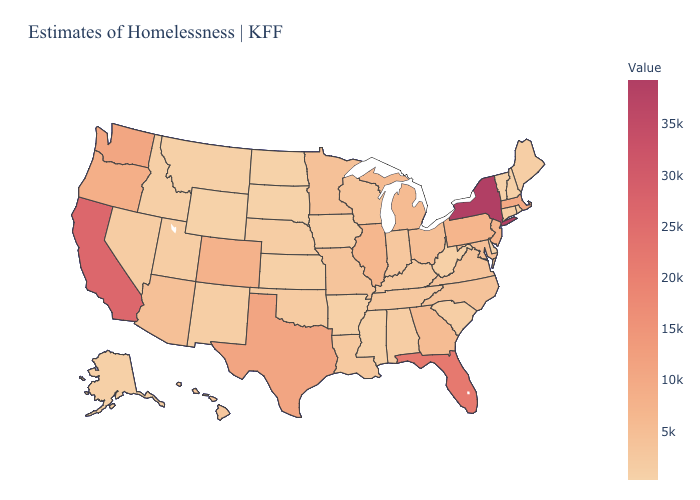Does the map have missing data?
Keep it brief. No. Among the states that border Florida , which have the highest value?
Keep it brief. Georgia. Does Wyoming have the lowest value in the USA?
Write a very short answer. Yes. Does New York have the highest value in the USA?
Answer briefly. Yes. Does Wyoming have the lowest value in the USA?
Give a very brief answer. Yes. Does Utah have a lower value than Colorado?
Quick response, please. Yes. 